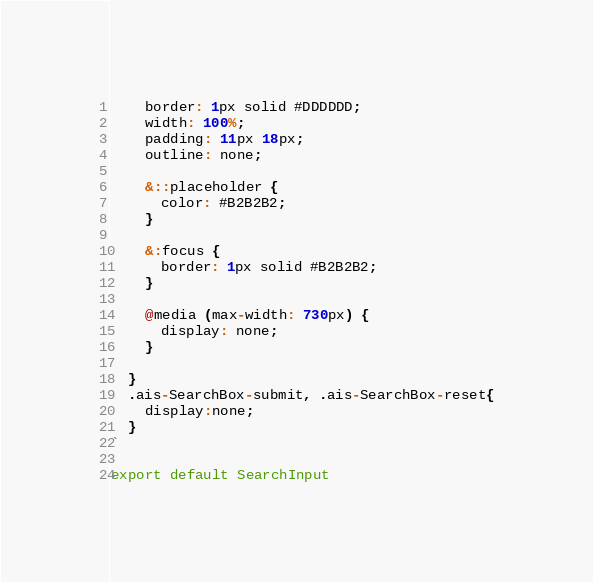Convert code to text. <code><loc_0><loc_0><loc_500><loc_500><_JavaScript_>    border: 1px solid #DDDDDD;
    width: 100%;
    padding: 11px 18px;
    outline: none;
  
    &::placeholder {
      color: #B2B2B2;
    }
  
    &:focus {
      border: 1px solid #B2B2B2;
    }
  
    @media (max-width: 730px) {
      display: none;
    }
    
  }
  .ais-SearchBox-submit, .ais-SearchBox-reset{
    display:none;
  }
`

export default SearchInput
</code> 